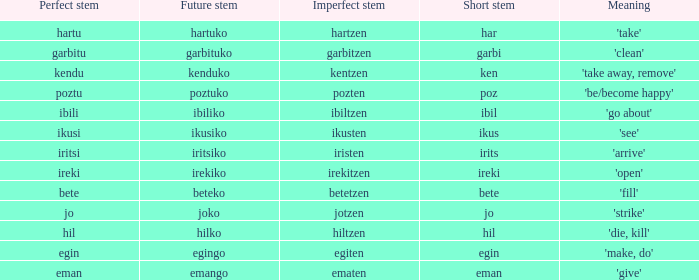What is the concise base of garbitzen? Garbi. 